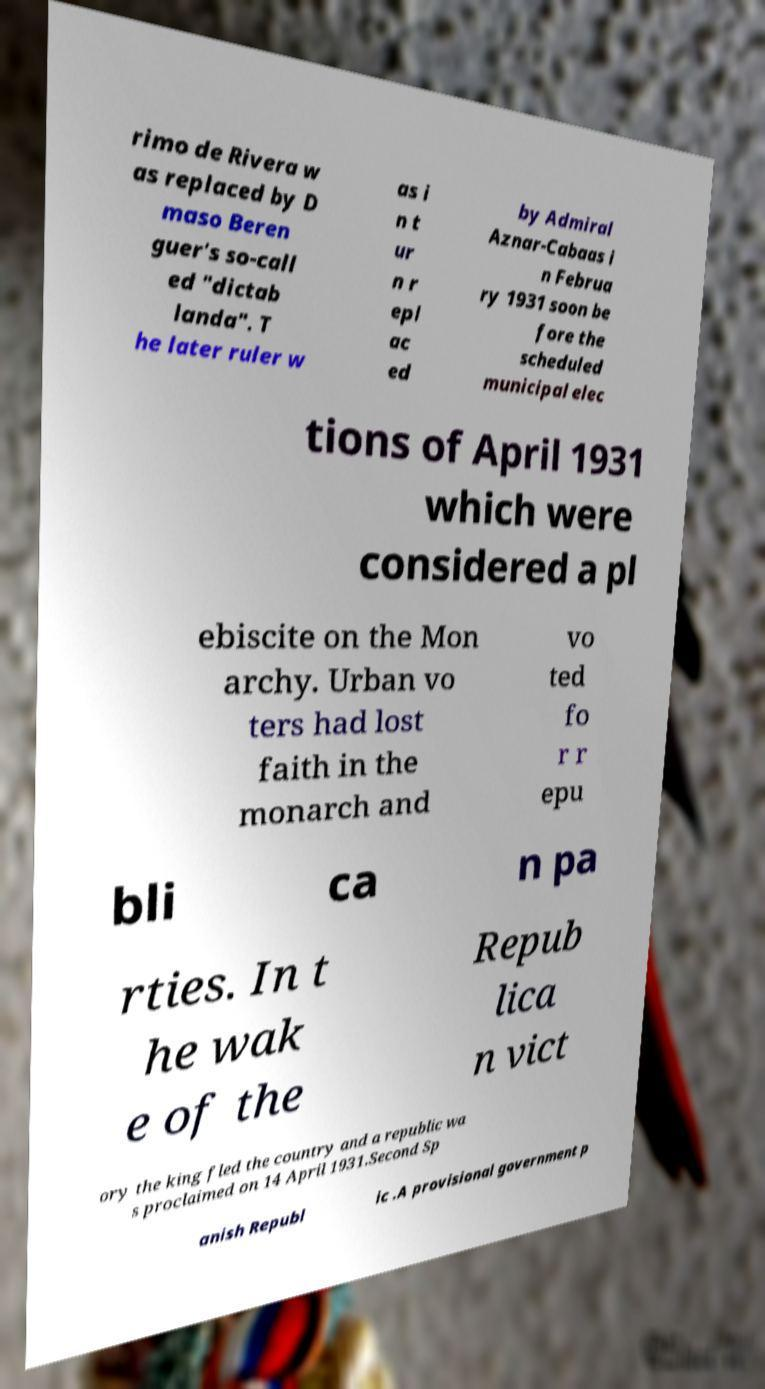Could you assist in decoding the text presented in this image and type it out clearly? rimo de Rivera w as replaced by D maso Beren guer's so-call ed "dictab landa". T he later ruler w as i n t ur n r epl ac ed by Admiral Aznar-Cabaas i n Februa ry 1931 soon be fore the scheduled municipal elec tions of April 1931 which were considered a pl ebiscite on the Mon archy. Urban vo ters had lost faith in the monarch and vo ted fo r r epu bli ca n pa rties. In t he wak e of the Repub lica n vict ory the king fled the country and a republic wa s proclaimed on 14 April 1931.Second Sp anish Republ ic .A provisional government p 